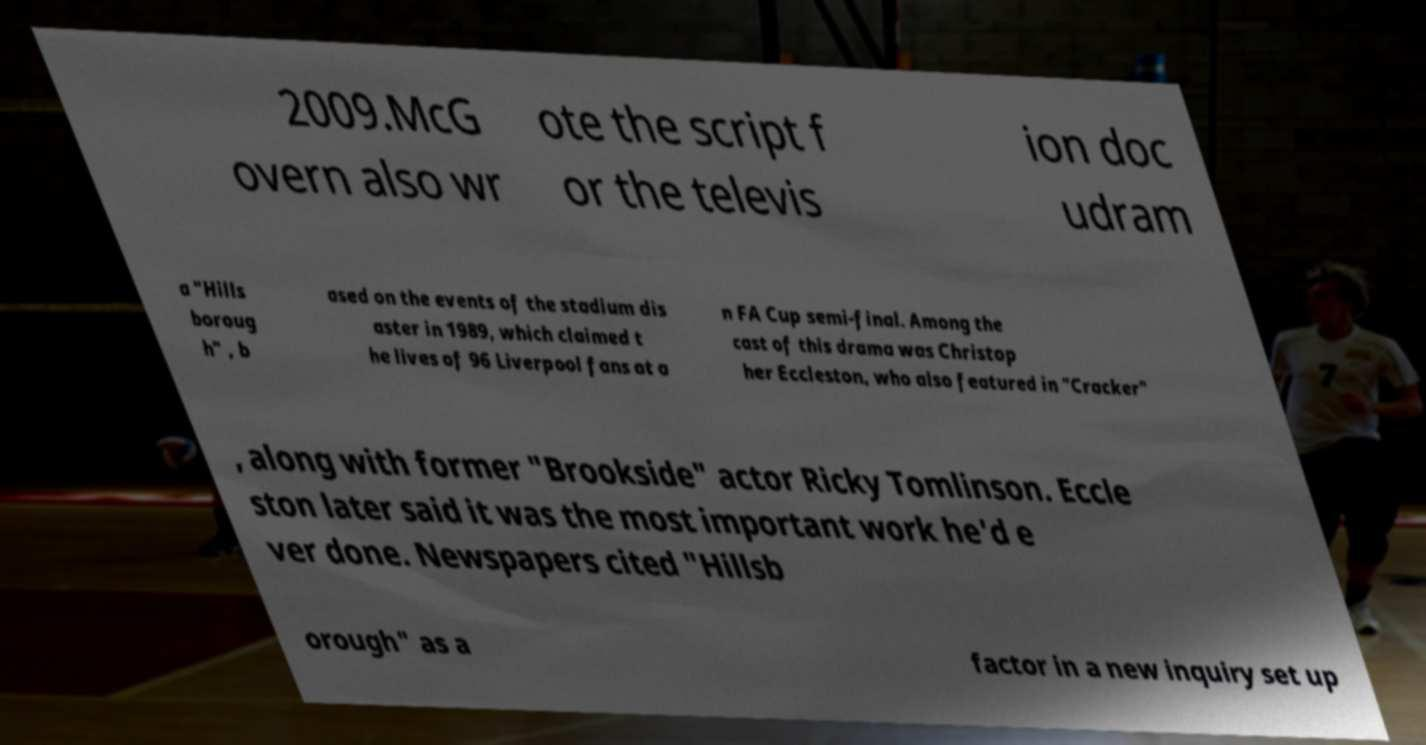Please identify and transcribe the text found in this image. 2009.McG overn also wr ote the script f or the televis ion doc udram a "Hills boroug h" , b ased on the events of the stadium dis aster in 1989, which claimed t he lives of 96 Liverpool fans at a n FA Cup semi-final. Among the cast of this drama was Christop her Eccleston, who also featured in "Cracker" , along with former "Brookside" actor Ricky Tomlinson. Eccle ston later said it was the most important work he'd e ver done. Newspapers cited "Hillsb orough" as a factor in a new inquiry set up 